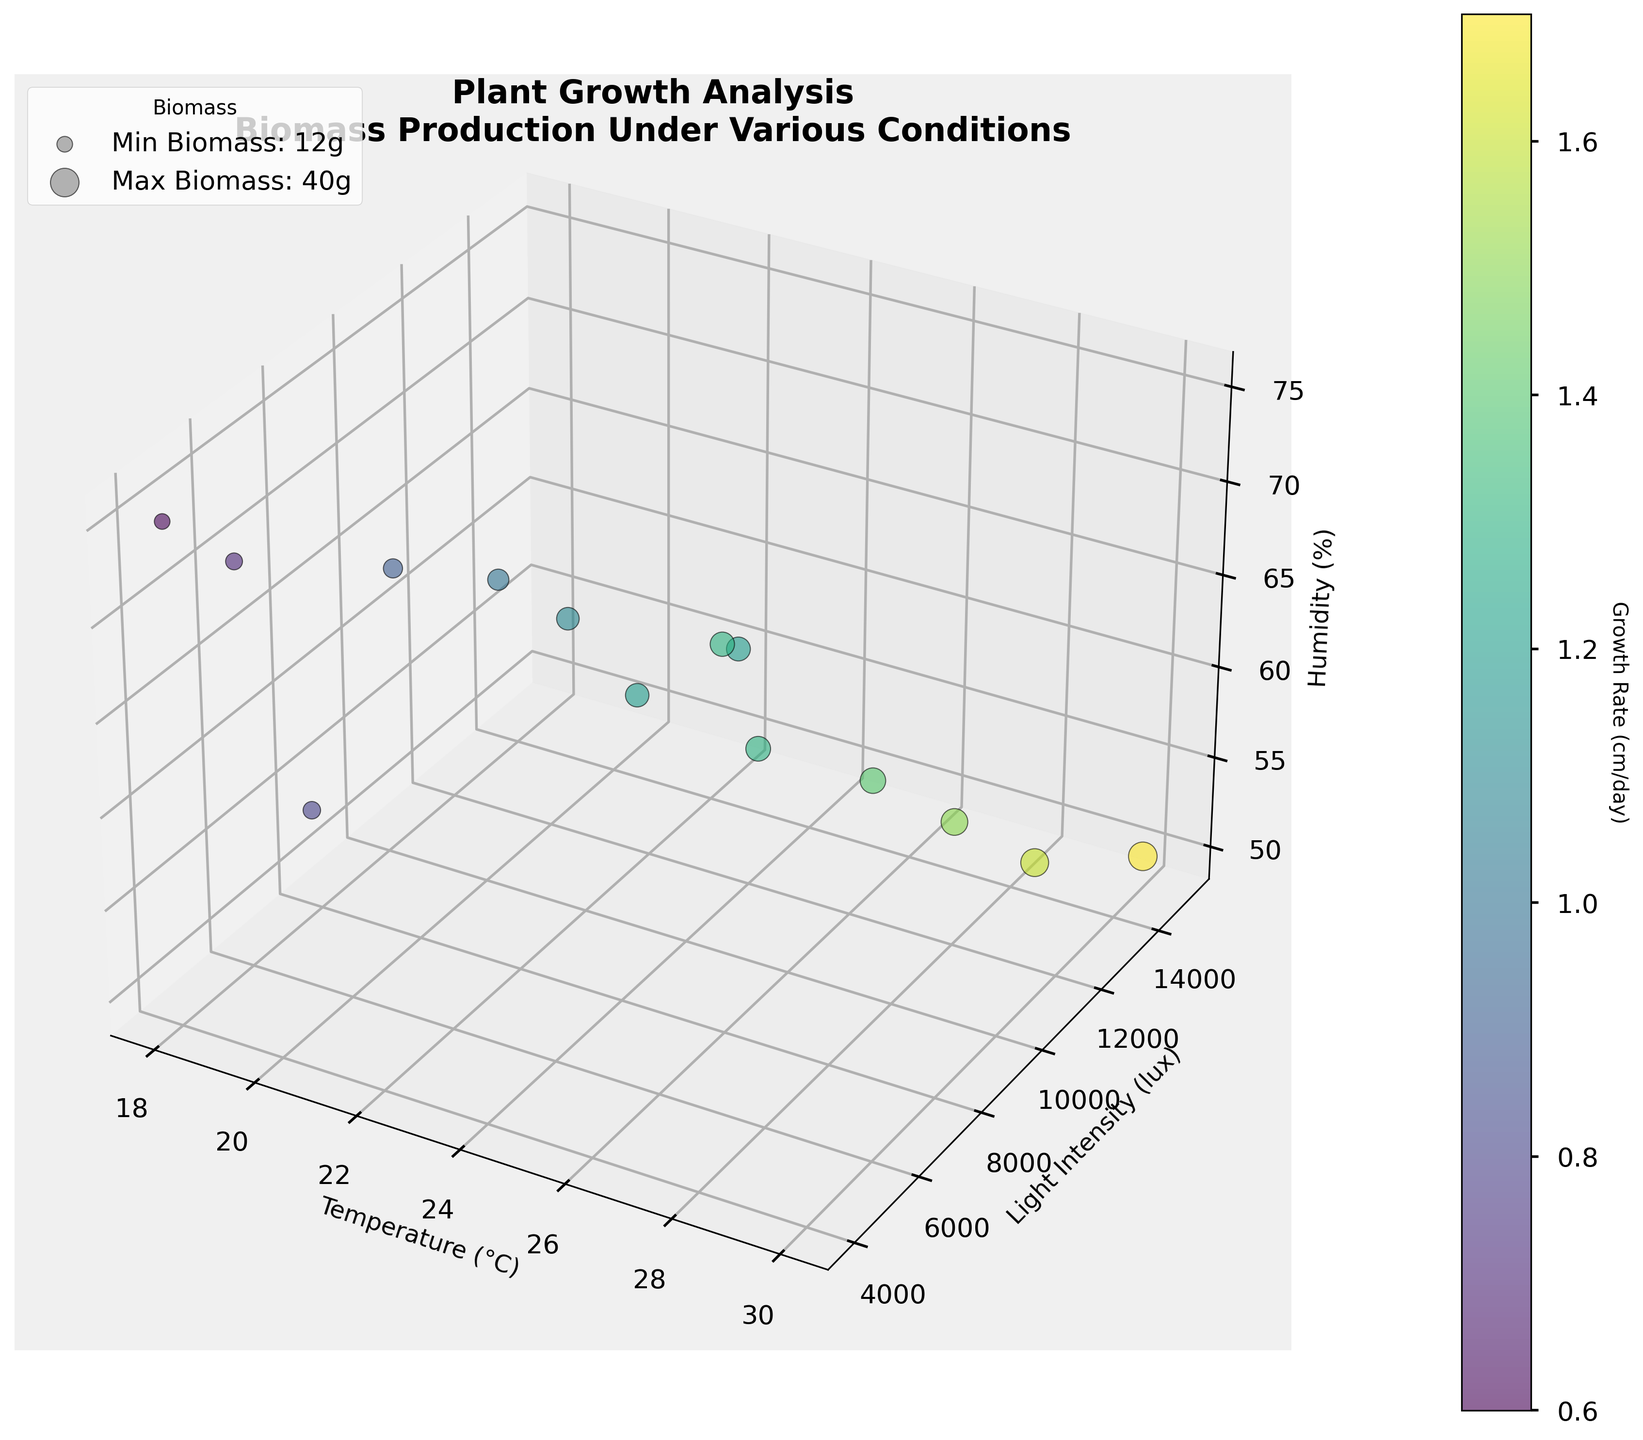How many environmental conditions (data points) are there in the figure? Count the number of bubbles in the plot. Each bubble represents a set of environmental conditions.
Answer: 14 What is the title of the figure? Read the title displayed at the top of the figure.
Answer: "Plant Growth Analysis\nBiomass Production Under Various Conditions" Which environmental condition results in the highest plant growth rate? Identify the bubble with the highest color intensity, corresponding to the highest growth rate. Check the legend for exact mapping to growth rate values.
Answer: 30°C, 15000 lux, 50% What are the labels of the axes? Read the labels along the X, Y, and Z axes.
Answer: Temperature (°C), Light Intensity (lux), Humidity (%) Which condition has the largest biomass production? Look for the biggest bubble size, as size corresponds to biomass production. Refer to the legend for clarification.
Answer: 30°C, 15000 lux, 50% What is the temperature and light intensity of the condition with the lowest growth rate? Find the bubble with the lowest color intensity, corresponding to the lowest growth rate. Check the exact mapping.
Answer: 18°C, 4000 lux How does humidity correlate with growth rate in the visualized conditions? Observe any trends or patterns between bubble positions on the Z-axis (Humidity) and their color intensities (Growth Rate).
Answer: No direct trend, mixed correlation Compare the plant growth rate at 25°C with the growth rate at 20°C. Compare the colors of the bubbles corresponding to 25°C and 20°C to see which is more intense. More intensity signifies a higher growth rate.
Answer: 25°C is higher If you average the light intensity values for conditions with temperatures above 25°C, what is the result? Extract light intensity values for points where Temperature > 25°C, sum them up, and then divide by the number of such points.
Answer: (12000 + 11000 + 13000 + 15000) / 4 = 12750 What is the maximum humidity percentage in the dataset? Identify the maximum value along the Z-axis (Humidity %).
Answer: 75% How does biomass production vary with temperature? Observe the size of bubbles (biomass production) along the X-axis (Temperature) to identify any trends or patterns.
Answer: Generally increases with temperature 